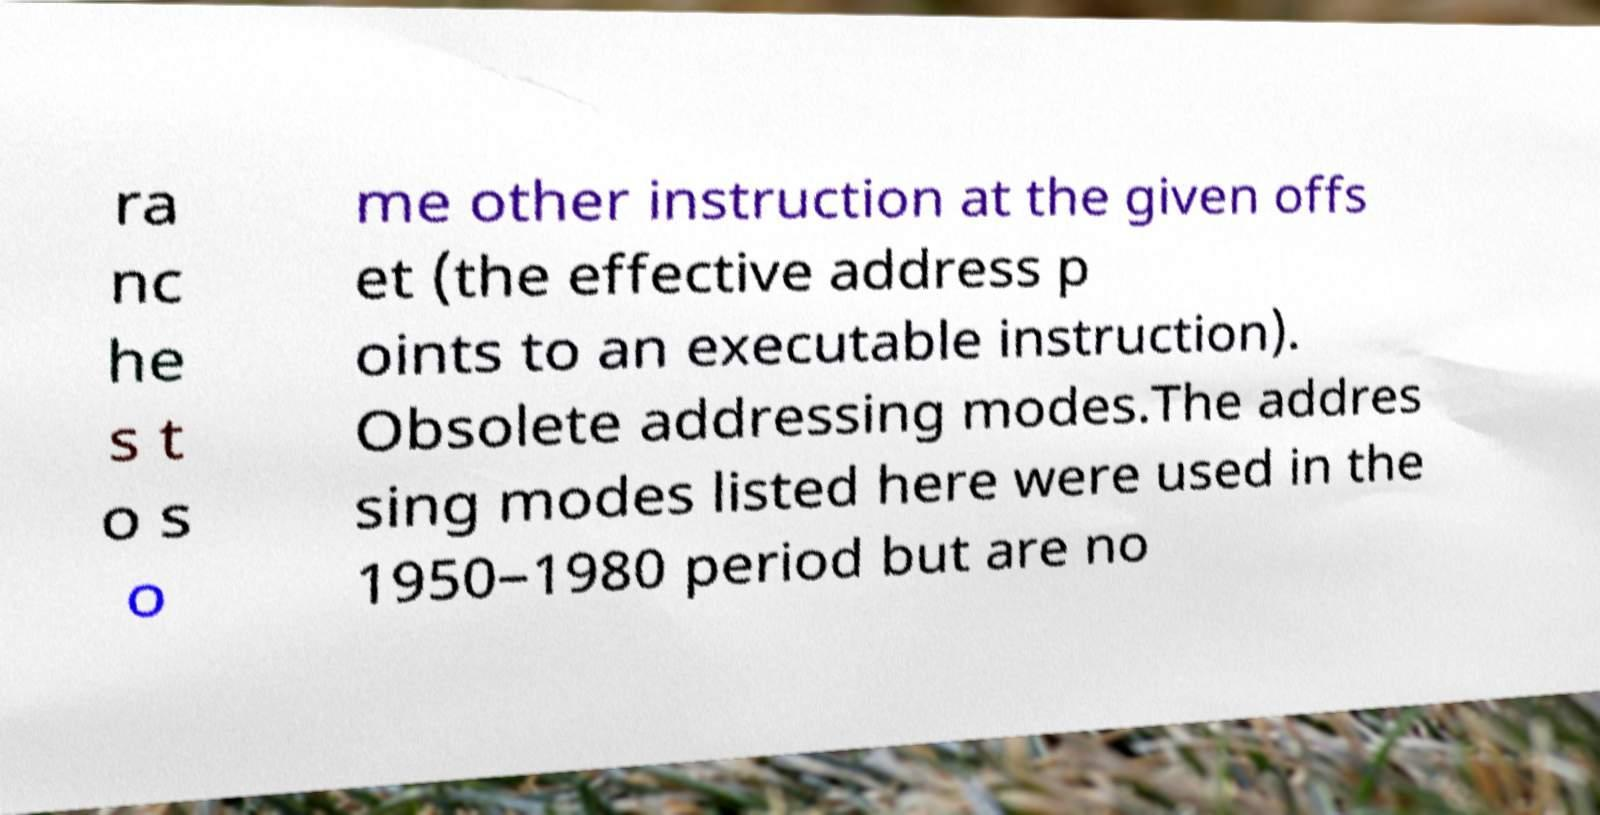There's text embedded in this image that I need extracted. Can you transcribe it verbatim? ra nc he s t o s o me other instruction at the given offs et (the effective address p oints to an executable instruction). Obsolete addressing modes.The addres sing modes listed here were used in the 1950–1980 period but are no 